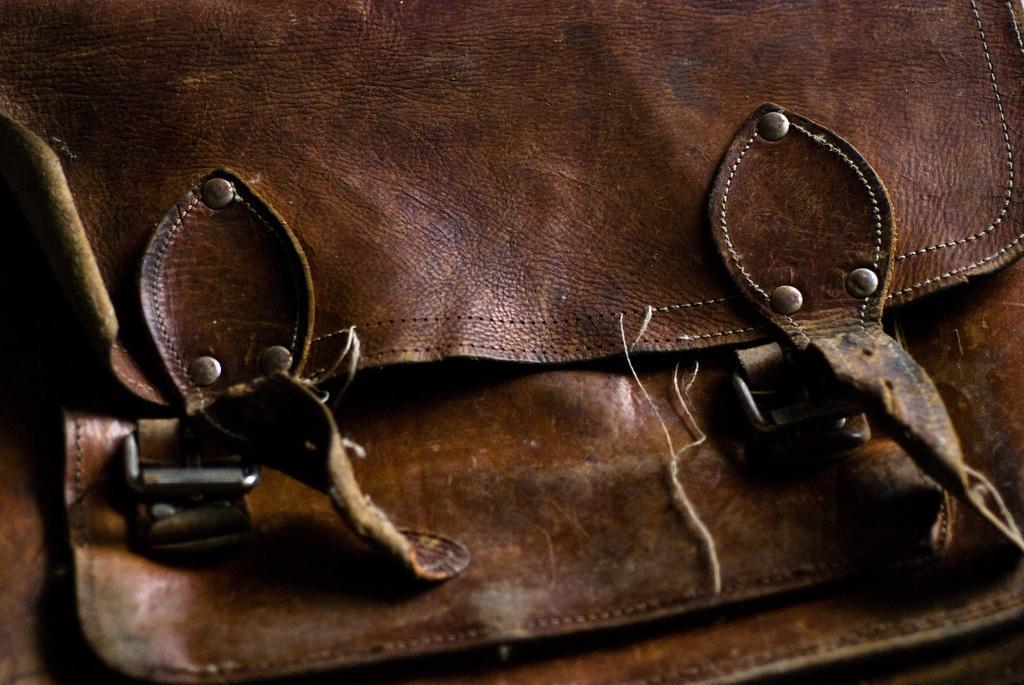How would you summarize this image in a sentence or two? In this picture we can see a bag which is in brown color. 